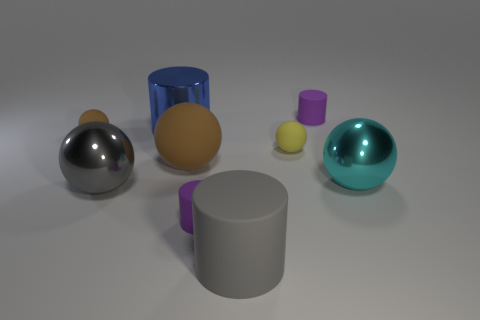Subtract all yellow balls. How many balls are left? 4 Subtract all large brown balls. How many balls are left? 4 Subtract all blue balls. Subtract all gray cylinders. How many balls are left? 5 Add 1 tiny red cylinders. How many objects exist? 10 Subtract all cylinders. How many objects are left? 5 Subtract all large brown matte balls. Subtract all large blue cylinders. How many objects are left? 7 Add 5 yellow matte things. How many yellow matte things are left? 6 Add 6 big cylinders. How many big cylinders exist? 8 Subtract 0 yellow blocks. How many objects are left? 9 